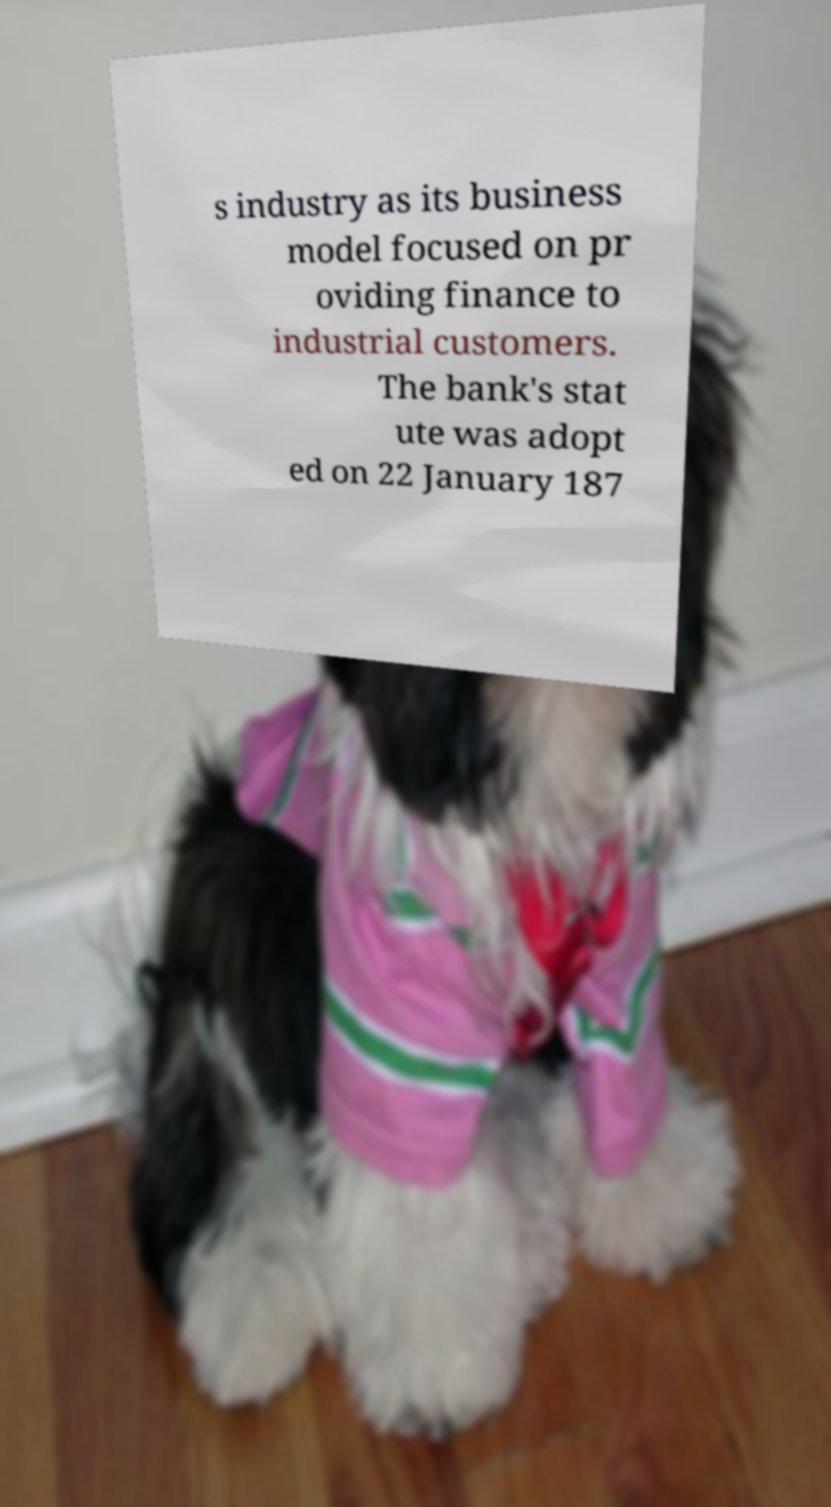Could you extract and type out the text from this image? s industry as its business model focused on pr oviding finance to industrial customers. The bank's stat ute was adopt ed on 22 January 187 